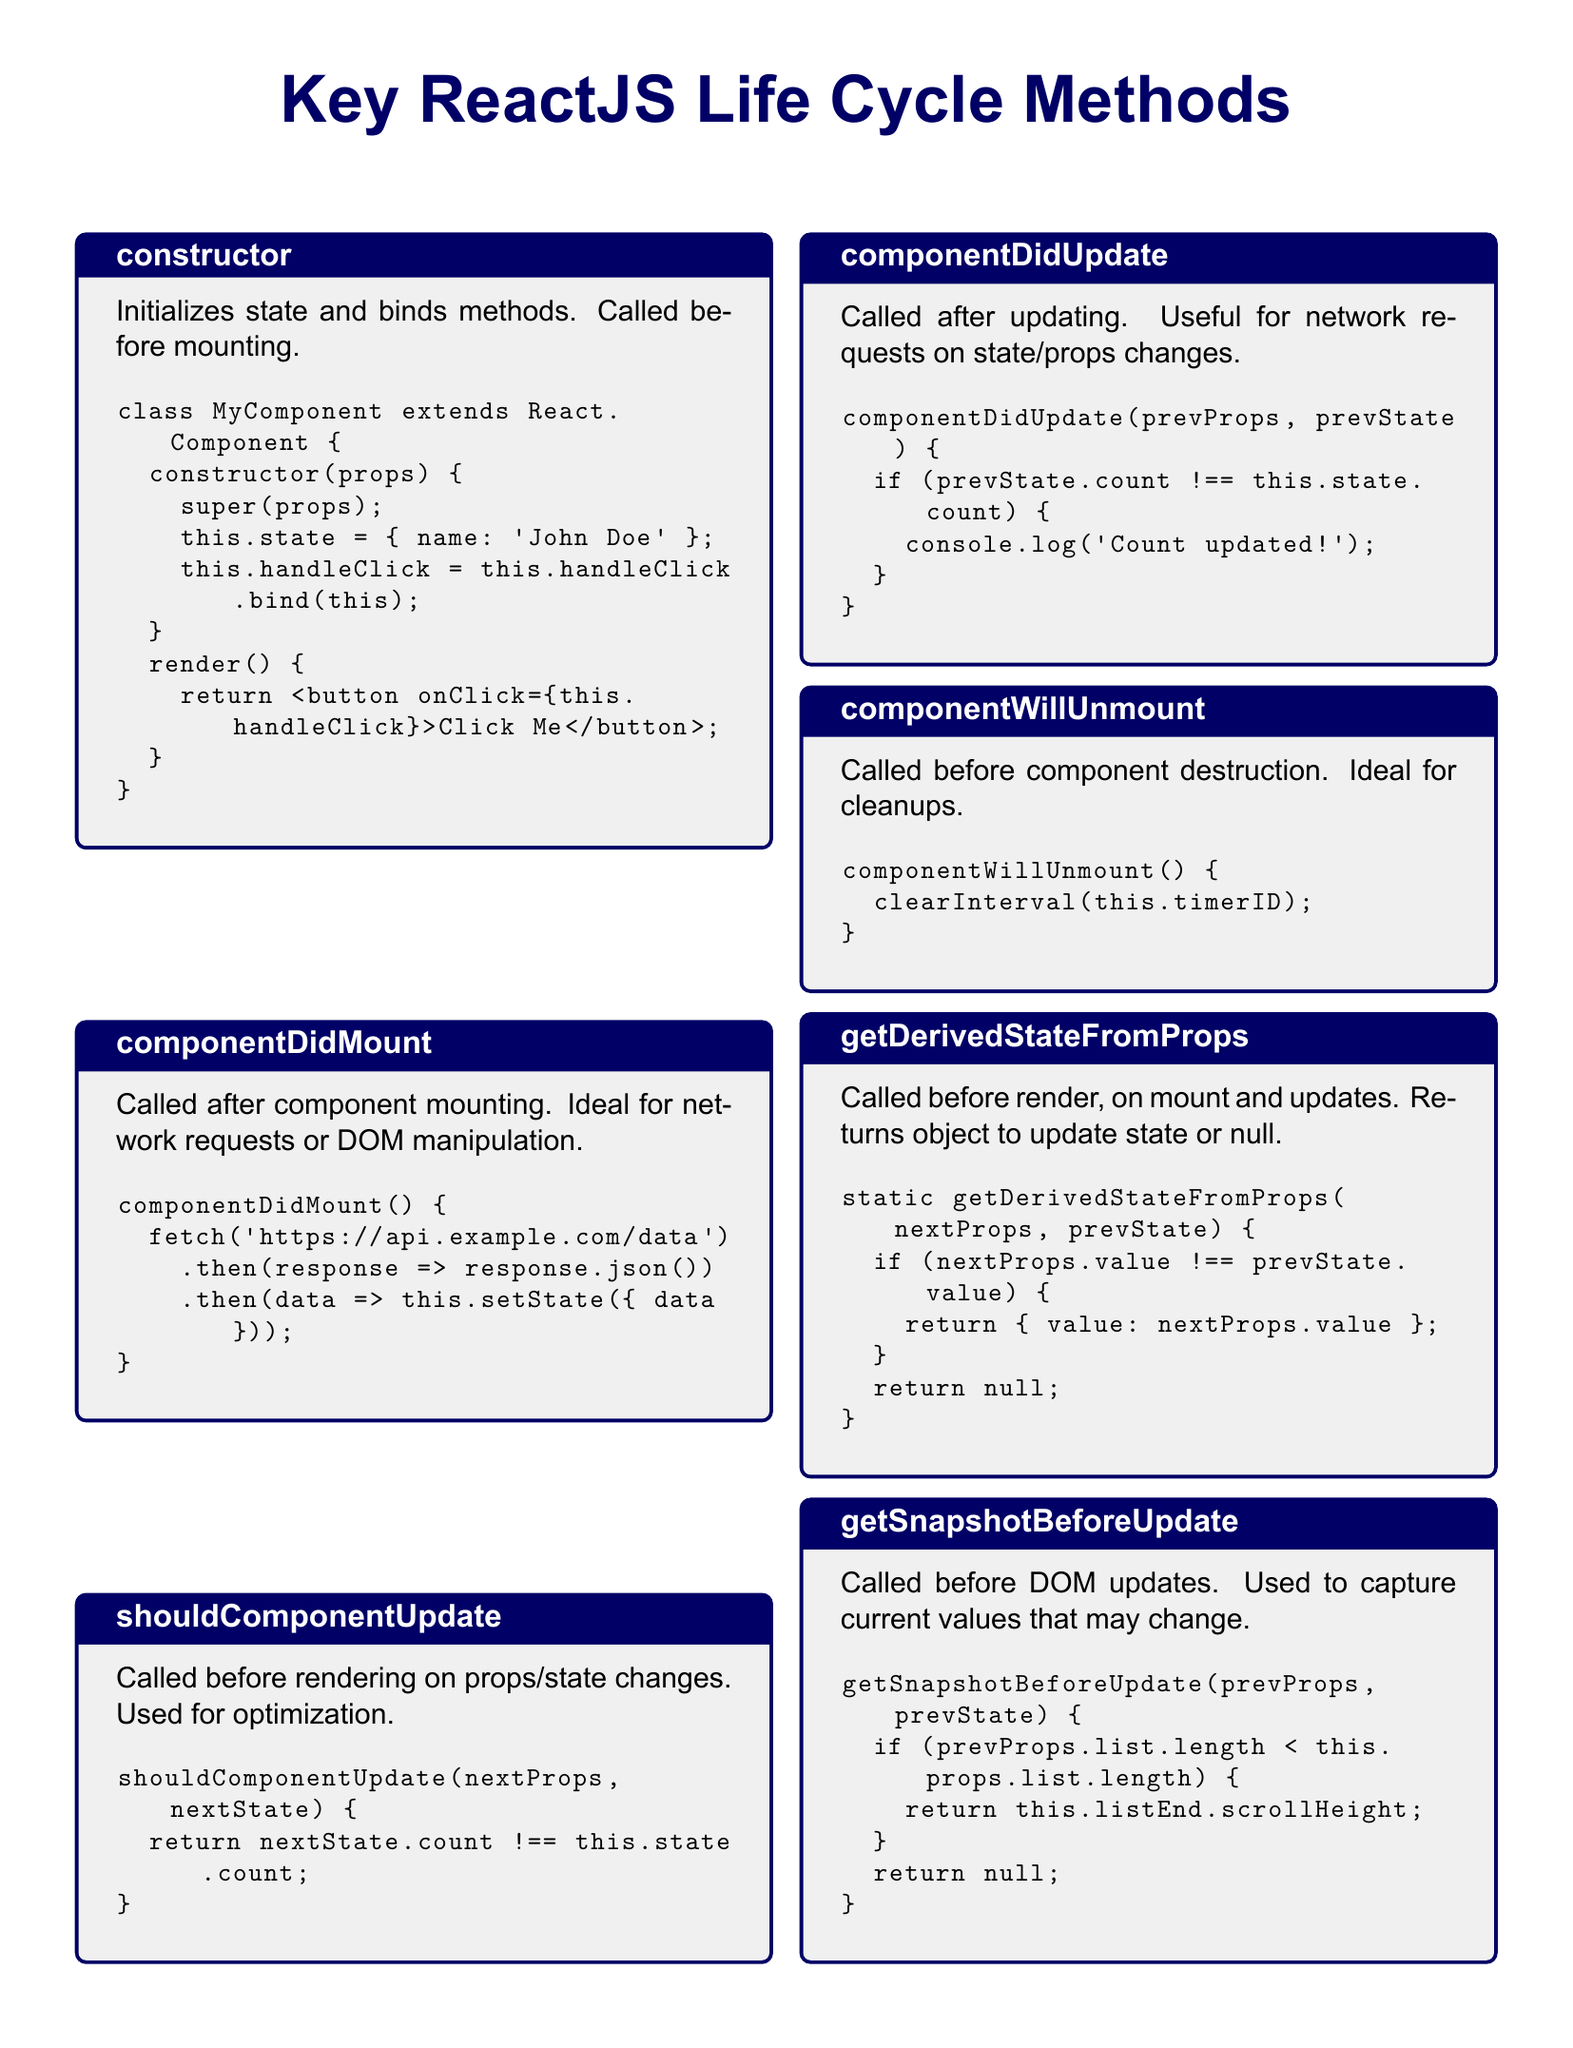What is the first life cycle method listed? The first life cycle method mentioned in the document is the constructor, which is used to initialize state and bind methods.
Answer: constructor What is the purpose of componentDidMount? The purpose of componentDidMount is to perform actions after the component has mounted, such as making network requests or manipulating the DOM.
Answer: Network requests or DOM manipulation How many life cycle methods are detailed in the document? There are a total of seven life cycle methods detailed in the document.
Answer: seven What does shouldComponentUpdate return if the count state has changed? shouldComponentUpdate returns true if the count state has changed, allowing the component to re-render.
Answer: true What cleanup action is suggested in componentWillUnmount? In componentWillUnmount, it is suggested to clear the interval timer before the component is destroyed.
Answer: clear interval Which method is called before a component is rendered? getDerivedStateFromProps is called before the component is rendered on mount and updates to determine if the state should be updated.
Answer: getDerivedStateFromProps What information does getSnapshotBeforeUpdate capture? getSnapshotBeforeUpdate captures current values of props or state that may change before the component updates the DOM.
Answer: current values What is returned by getDerivedStateFromProps if the value prop has not changed? If the value prop has not changed, getDerivedStateFromProps returns null, indicating no state change is needed.
Answer: null 